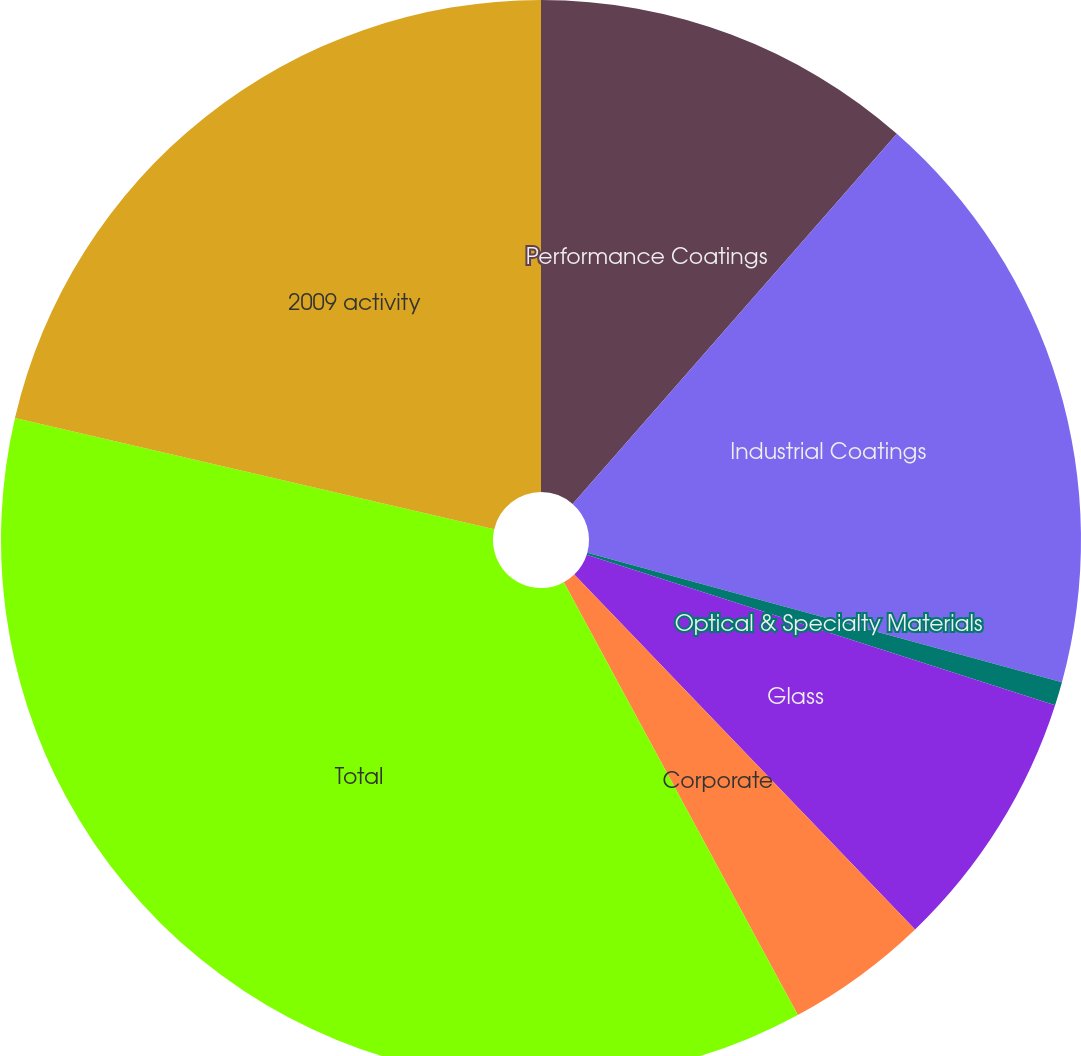<chart> <loc_0><loc_0><loc_500><loc_500><pie_chart><fcel>Performance Coatings<fcel>Industrial Coatings<fcel>Optical & Specialty Materials<fcel>Glass<fcel>Corporate<fcel>Total<fcel>2009 activity<nl><fcel>11.45%<fcel>17.79%<fcel>0.71%<fcel>7.87%<fcel>4.29%<fcel>36.52%<fcel>21.37%<nl></chart> 